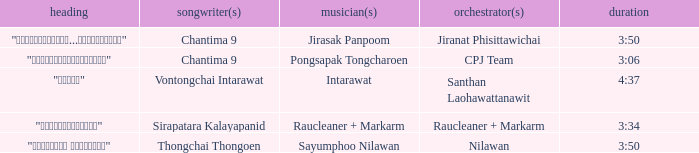Who was the arranger for the song that had a lyricist of Sirapatara Kalayapanid? Raucleaner + Markarm. 